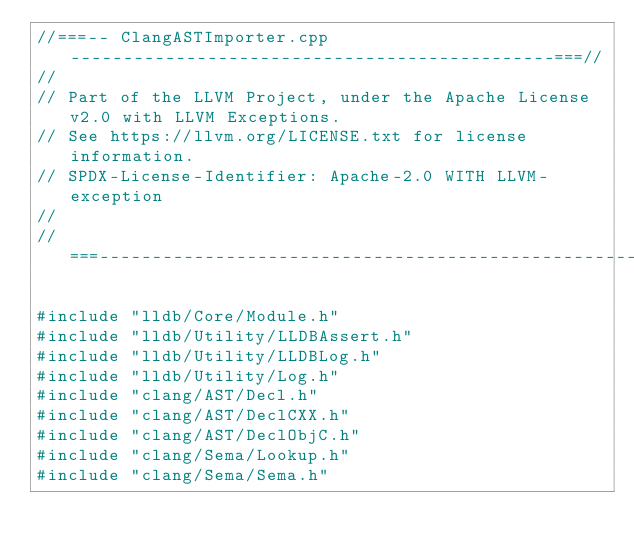Convert code to text. <code><loc_0><loc_0><loc_500><loc_500><_C++_>//===-- ClangASTImporter.cpp ----------------------------------------------===//
//
// Part of the LLVM Project, under the Apache License v2.0 with LLVM Exceptions.
// See https://llvm.org/LICENSE.txt for license information.
// SPDX-License-Identifier: Apache-2.0 WITH LLVM-exception
//
//===----------------------------------------------------------------------===//

#include "lldb/Core/Module.h"
#include "lldb/Utility/LLDBAssert.h"
#include "lldb/Utility/LLDBLog.h"
#include "lldb/Utility/Log.h"
#include "clang/AST/Decl.h"
#include "clang/AST/DeclCXX.h"
#include "clang/AST/DeclObjC.h"
#include "clang/Sema/Lookup.h"
#include "clang/Sema/Sema.h"</code> 